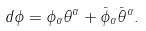Convert formula to latex. <formula><loc_0><loc_0><loc_500><loc_500>d \phi = \phi _ { \alpha } \theta ^ { \alpha } + \bar { \phi } _ { \alpha } \bar { \theta } ^ { \alpha } .</formula> 